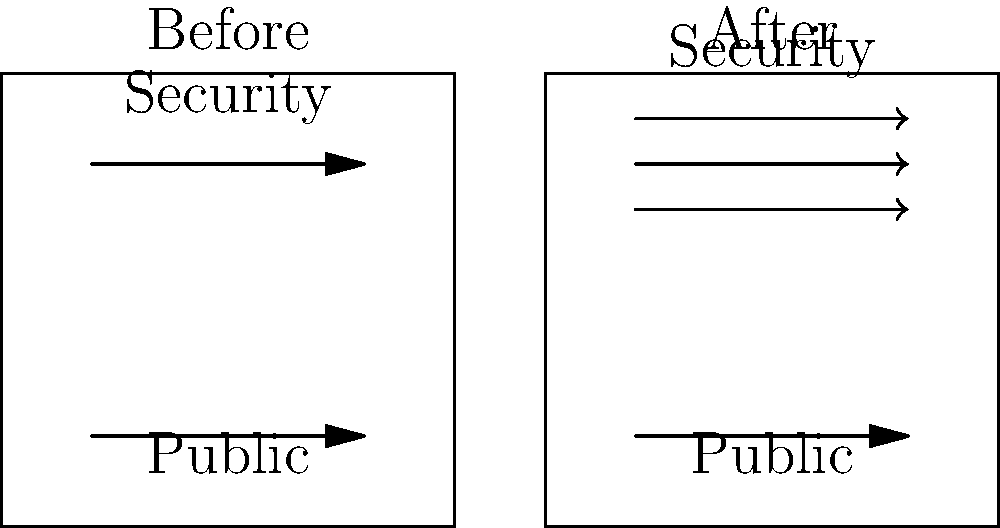Based on the diagram, which of the following statements best describes the change in security measures after the terror attack?

A) Security measures remained unchanged
B) Security measures slightly increased
C) Security measures significantly increased
D) Security measures decreased To analyze the increase in security measures post-attack, let's examine the diagram step-by-step:

1. Before the attack:
   - There is one arrow representing security measures.
   - One arrow represents public access.

2. After the attack:
   - There are three arrows representing security measures.
   - One arrow still represents public access.

3. Comparing before and after:
   - The number of security measure arrows increased from 1 to 3.
   - Public access representation remained the same.

4. Interpretation:
   - The tripling of security measure arrows indicates a significant increase in security.
   - The consistency in public access representation suggests that public movement was not completely restricted.

5. Conclusion:
   - The diagram clearly shows a substantial increase in security measures after the attack.
   - This increase is best described as "significant" rather than "slight" or "unchanged."

Therefore, the correct answer is that security measures significantly increased after the terror attack.
Answer: C) Security measures significantly increased 